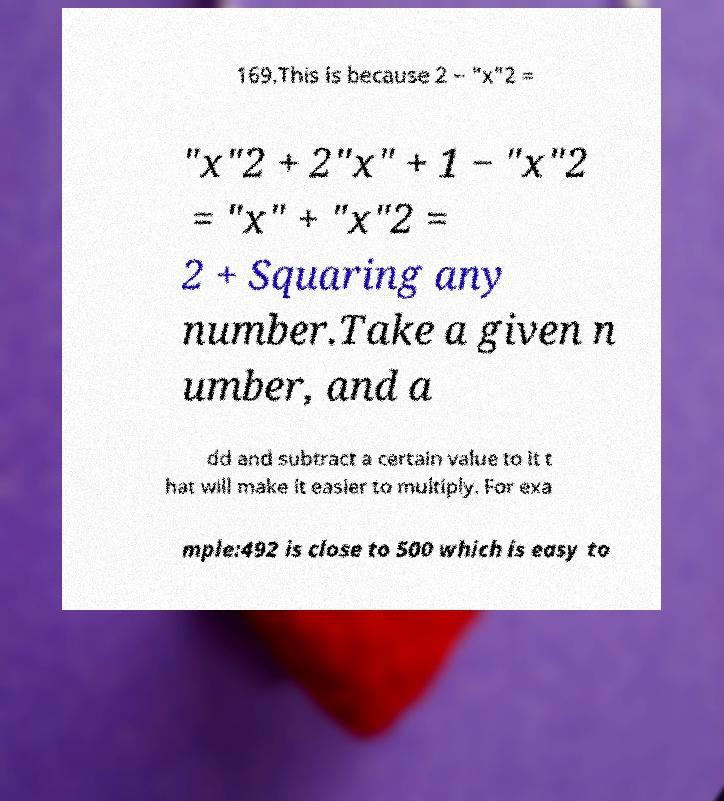Please identify and transcribe the text found in this image. 169.This is because 2 − "x"2 = "x"2 + 2"x" + 1 − "x"2 = "x" + "x"2 = 2 + Squaring any number.Take a given n umber, and a dd and subtract a certain value to it t hat will make it easier to multiply. For exa mple:492 is close to 500 which is easy to 